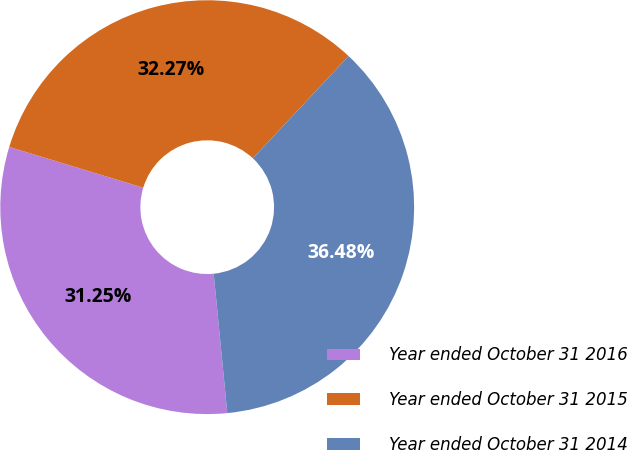<chart> <loc_0><loc_0><loc_500><loc_500><pie_chart><fcel>Year ended October 31 2016<fcel>Year ended October 31 2015<fcel>Year ended October 31 2014<nl><fcel>31.25%<fcel>32.27%<fcel>36.48%<nl></chart> 